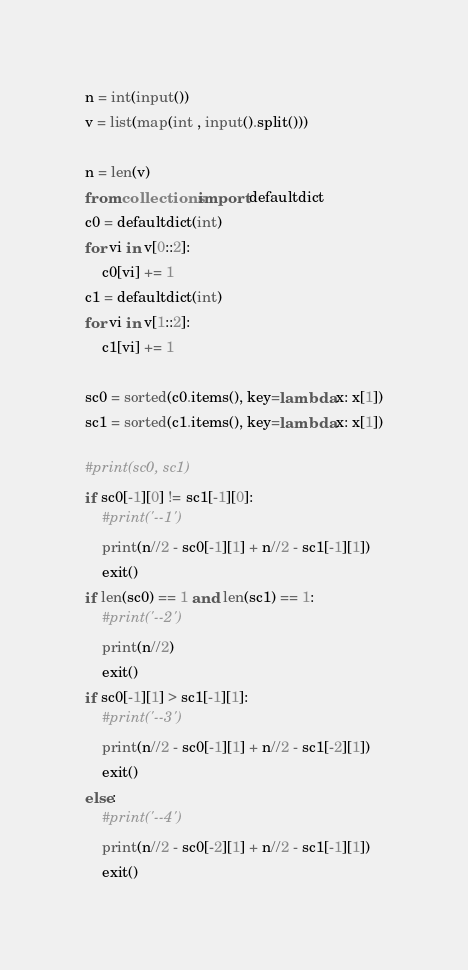Convert code to text. <code><loc_0><loc_0><loc_500><loc_500><_Python_>n = int(input())
v = list(map(int , input().split()))

n = len(v)
from collections import defaultdict
c0 = defaultdict(int)
for vi in v[0::2]:
    c0[vi] += 1
c1 = defaultdict(int)
for vi in v[1::2]:
    c1[vi] += 1

sc0 = sorted(c0.items(), key=lambda x: x[1])
sc1 = sorted(c1.items(), key=lambda x: x[1])

#print(sc0, sc1)
if sc0[-1][0] != sc1[-1][0]:
    #print('--1')
    print(n//2 - sc0[-1][1] + n//2 - sc1[-1][1])
    exit()
if len(sc0) == 1 and len(sc1) == 1:
    #print('--2')
    print(n//2)
    exit()
if sc0[-1][1] > sc1[-1][1]:
    #print('--3')
    print(n//2 - sc0[-1][1] + n//2 - sc1[-2][1])
    exit()
else:
    #print('--4')
    print(n//2 - sc0[-2][1] + n//2 - sc1[-1][1])
    exit()

</code> 